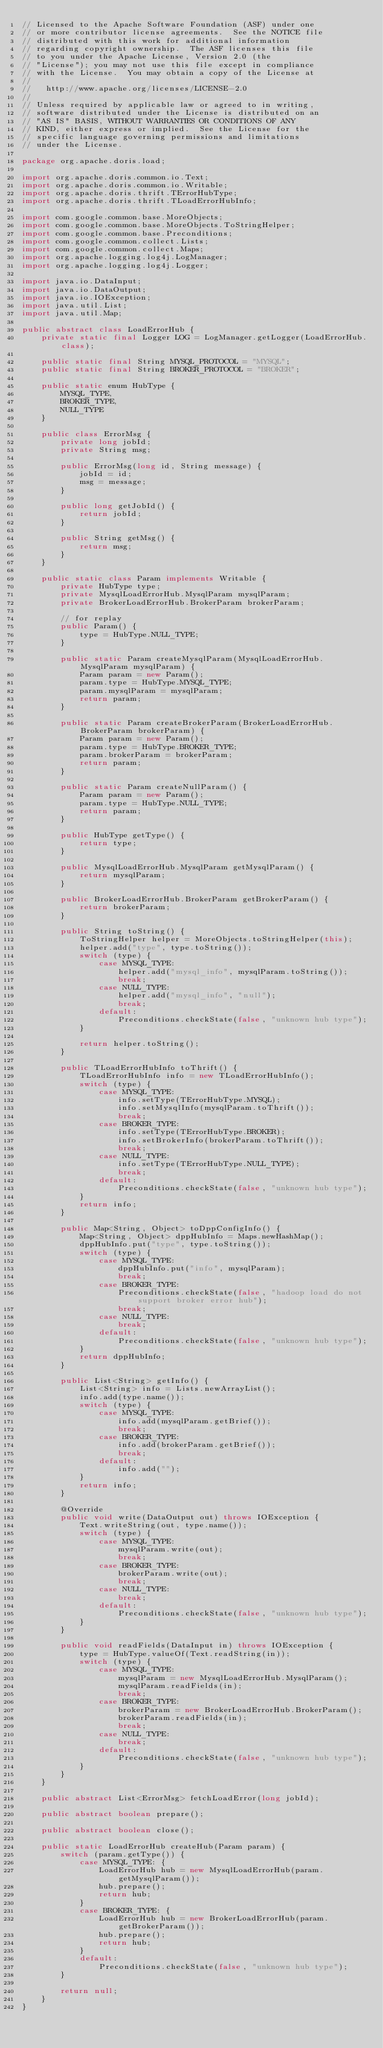Convert code to text. <code><loc_0><loc_0><loc_500><loc_500><_Java_>// Licensed to the Apache Software Foundation (ASF) under one
// or more contributor license agreements.  See the NOTICE file
// distributed with this work for additional information
// regarding copyright ownership.  The ASF licenses this file
// to you under the Apache License, Version 2.0 (the
// "License"); you may not use this file except in compliance
// with the License.  You may obtain a copy of the License at
//
//   http://www.apache.org/licenses/LICENSE-2.0
//
// Unless required by applicable law or agreed to in writing,
// software distributed under the License is distributed on an
// "AS IS" BASIS, WITHOUT WARRANTIES OR CONDITIONS OF ANY
// KIND, either express or implied.  See the License for the
// specific language governing permissions and limitations
// under the License.

package org.apache.doris.load;

import org.apache.doris.common.io.Text;
import org.apache.doris.common.io.Writable;
import org.apache.doris.thrift.TErrorHubType;
import org.apache.doris.thrift.TLoadErrorHubInfo;

import com.google.common.base.MoreObjects;
import com.google.common.base.MoreObjects.ToStringHelper;
import com.google.common.base.Preconditions;
import com.google.common.collect.Lists;
import com.google.common.collect.Maps;
import org.apache.logging.log4j.LogManager;
import org.apache.logging.log4j.Logger;

import java.io.DataInput;
import java.io.DataOutput;
import java.io.IOException;
import java.util.List;
import java.util.Map;

public abstract class LoadErrorHub {
    private static final Logger LOG = LogManager.getLogger(LoadErrorHub.class);

    public static final String MYSQL_PROTOCOL = "MYSQL";
    public static final String BROKER_PROTOCOL = "BROKER";

    public static enum HubType {
        MYSQL_TYPE,
        BROKER_TYPE,
        NULL_TYPE
    }

    public class ErrorMsg {
        private long jobId;
        private String msg;

        public ErrorMsg(long id, String message) {
            jobId = id;
            msg = message;
        }

        public long getJobId() {
            return jobId;
        }

        public String getMsg() {
            return msg;
        }
    }

    public static class Param implements Writable {
        private HubType type;
        private MysqlLoadErrorHub.MysqlParam mysqlParam;
        private BrokerLoadErrorHub.BrokerParam brokerParam;

        // for replay
        public Param() {
            type = HubType.NULL_TYPE;
        }

        public static Param createMysqlParam(MysqlLoadErrorHub.MysqlParam mysqlParam) {
            Param param = new Param();
            param.type = HubType.MYSQL_TYPE;
            param.mysqlParam = mysqlParam;
            return param;
        }

        public static Param createBrokerParam(BrokerLoadErrorHub.BrokerParam brokerParam) {
            Param param = new Param();
            param.type = HubType.BROKER_TYPE;
            param.brokerParam = brokerParam;
            return param;
        }

        public static Param createNullParam() {
            Param param = new Param();
            param.type = HubType.NULL_TYPE;
            return param;
        }

        public HubType getType() {
            return type;
        }

        public MysqlLoadErrorHub.MysqlParam getMysqlParam() {
            return mysqlParam;
        }

        public BrokerLoadErrorHub.BrokerParam getBrokerParam() {
            return brokerParam;
        }

        public String toString() {
            ToStringHelper helper = MoreObjects.toStringHelper(this);
            helper.add("type", type.toString());
            switch (type) {
                case MYSQL_TYPE:
                    helper.add("mysql_info", mysqlParam.toString());
                    break;
                case NULL_TYPE:
                    helper.add("mysql_info", "null");
                    break;
                default:
                    Preconditions.checkState(false, "unknown hub type");
            }

            return helper.toString();
        }

        public TLoadErrorHubInfo toThrift() {
            TLoadErrorHubInfo info = new TLoadErrorHubInfo();
            switch (type) {
                case MYSQL_TYPE:
                    info.setType(TErrorHubType.MYSQL);
                    info.setMysqlInfo(mysqlParam.toThrift());
                    break;
                case BROKER_TYPE:
                    info.setType(TErrorHubType.BROKER);
                    info.setBrokerInfo(brokerParam.toThrift());
                    break;
                case NULL_TYPE:
                    info.setType(TErrorHubType.NULL_TYPE);
                    break;
                default:
                    Preconditions.checkState(false, "unknown hub type");
            }
            return info;
        }

        public Map<String, Object> toDppConfigInfo() {
            Map<String, Object> dppHubInfo = Maps.newHashMap();
            dppHubInfo.put("type", type.toString());
            switch (type) {
                case MYSQL_TYPE:
                    dppHubInfo.put("info", mysqlParam);
                    break;
                case BROKER_TYPE:
                    Preconditions.checkState(false, "hadoop load do not support broker error hub");
                    break;
                case NULL_TYPE:
                    break;
                default:
                    Preconditions.checkState(false, "unknown hub type");
            }
            return dppHubInfo;
        }

        public List<String> getInfo() {
            List<String> info = Lists.newArrayList();
            info.add(type.name());
            switch (type) {
                case MYSQL_TYPE:
                    info.add(mysqlParam.getBrief());
                    break;
                case BROKER_TYPE:
                    info.add(brokerParam.getBrief());
                    break;
                default:
                    info.add("");
            }
            return info;
        }

        @Override
        public void write(DataOutput out) throws IOException {
            Text.writeString(out, type.name());
            switch (type) {
                case MYSQL_TYPE:
                    mysqlParam.write(out);
                    break;
                case BROKER_TYPE:
                    brokerParam.write(out);
                    break;
                case NULL_TYPE:
                    break;
                default:
                    Preconditions.checkState(false, "unknown hub type");
            }
        }

        public void readFields(DataInput in) throws IOException {
            type = HubType.valueOf(Text.readString(in));
            switch (type) {
                case MYSQL_TYPE:
                    mysqlParam = new MysqlLoadErrorHub.MysqlParam();
                    mysqlParam.readFields(in);
                    break;
                case BROKER_TYPE:
                    brokerParam = new BrokerLoadErrorHub.BrokerParam();
                    brokerParam.readFields(in);
                    break;
                case NULL_TYPE:
                    break;
                default:
                    Preconditions.checkState(false, "unknown hub type");
            }
        }
    }

    public abstract List<ErrorMsg> fetchLoadError(long jobId);

    public abstract boolean prepare();

    public abstract boolean close();

    public static LoadErrorHub createHub(Param param) {
        switch (param.getType()) {
            case MYSQL_TYPE: {
                LoadErrorHub hub = new MysqlLoadErrorHub(param.getMysqlParam());
                hub.prepare();
                return hub;
            }
            case BROKER_TYPE: {
                LoadErrorHub hub = new BrokerLoadErrorHub(param.getBrokerParam());
                hub.prepare();
                return hub;
            }
            default:
                Preconditions.checkState(false, "unknown hub type");
        }

        return null;
    }
}
</code> 